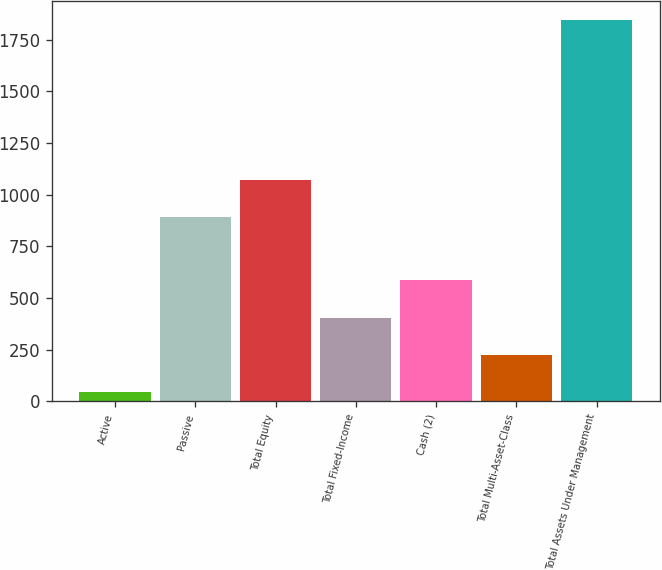Convert chart. <chart><loc_0><loc_0><loc_500><loc_500><bar_chart><fcel>Active<fcel>Passive<fcel>Total Equity<fcel>Total Fixed-Income<fcel>Cash (2)<fcel>Total Multi-Asset-Class<fcel>Total Assets Under Management<nl><fcel>46<fcel>893<fcel>1072.9<fcel>405.8<fcel>585.7<fcel>225.9<fcel>1845<nl></chart> 